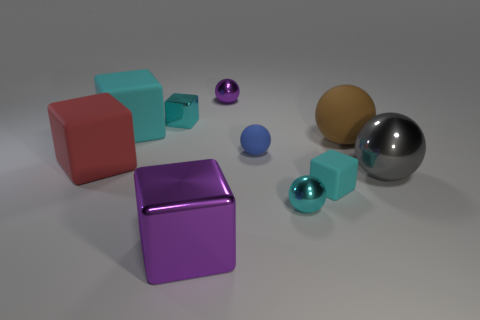The blue thing has what shape?
Offer a terse response. Sphere. There is a rubber block behind the red cube; does it have the same size as the shiny sphere in front of the big gray shiny object?
Make the answer very short. No. What size is the cyan matte block on the right side of the sphere behind the tiny thing that is left of the purple ball?
Offer a very short reply. Small. The tiny rubber object on the right side of the small metal thing that is to the right of the ball behind the small cyan metallic cube is what shape?
Keep it short and to the point. Cube. What is the shape of the cyan rubber thing in front of the brown matte ball?
Ensure brevity in your answer.  Cube. Are the tiny purple ball and the gray object that is on the right side of the brown object made of the same material?
Keep it short and to the point. Yes. How many other things are there of the same shape as the big purple metal object?
Provide a short and direct response. 4. There is a big metallic sphere; does it have the same color as the big ball behind the blue thing?
Provide a succinct answer. No. Are there any other things that are the same material as the red thing?
Provide a succinct answer. Yes. The big metal object that is in front of the metallic sphere on the right side of the small cyan rubber object is what shape?
Offer a very short reply. Cube. 